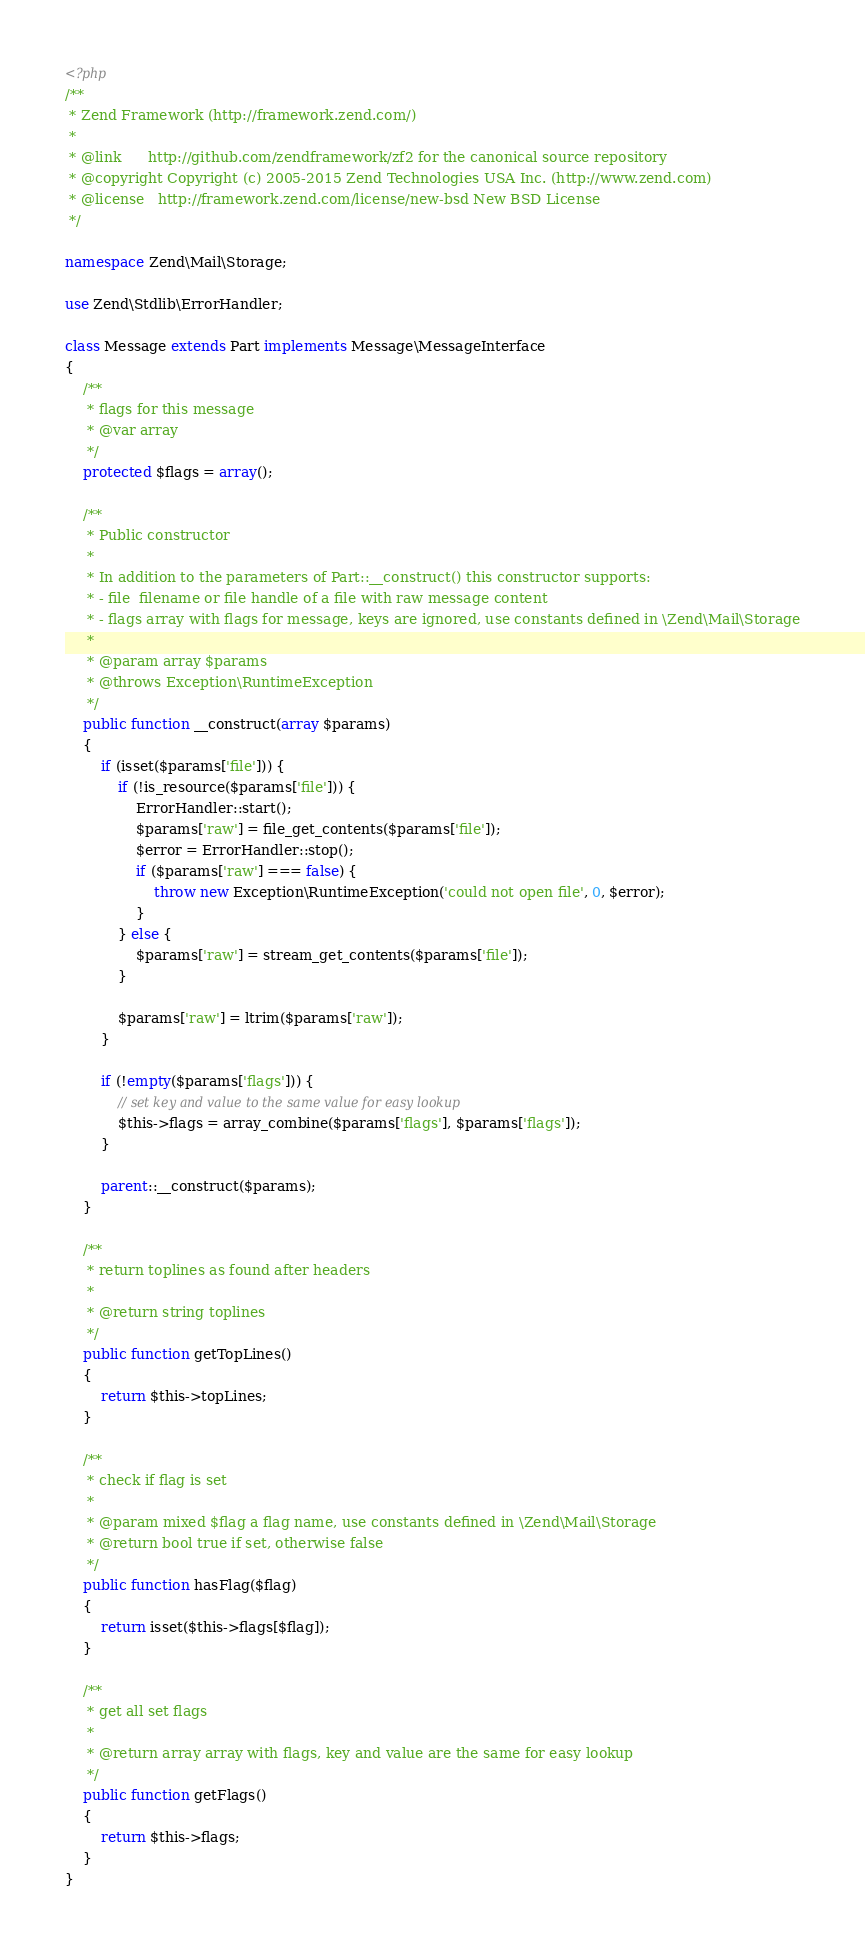<code> <loc_0><loc_0><loc_500><loc_500><_PHP_><?php
/**
 * Zend Framework (http://framework.zend.com/)
 *
 * @link      http://github.com/zendframework/zf2 for the canonical source repository
 * @copyright Copyright (c) 2005-2015 Zend Technologies USA Inc. (http://www.zend.com)
 * @license   http://framework.zend.com/license/new-bsd New BSD License
 */

namespace Zend\Mail\Storage;

use Zend\Stdlib\ErrorHandler;

class Message extends Part implements Message\MessageInterface
{
    /**
     * flags for this message
     * @var array
     */
    protected $flags = array();

    /**
     * Public constructor
     *
     * In addition to the parameters of Part::__construct() this constructor supports:
     * - file  filename or file handle of a file with raw message content
     * - flags array with flags for message, keys are ignored, use constants defined in \Zend\Mail\Storage
     *
     * @param array $params
     * @throws Exception\RuntimeException
     */
    public function __construct(array $params)
    {
        if (isset($params['file'])) {
            if (!is_resource($params['file'])) {
                ErrorHandler::start();
                $params['raw'] = file_get_contents($params['file']);
                $error = ErrorHandler::stop();
                if ($params['raw'] === false) {
                    throw new Exception\RuntimeException('could not open file', 0, $error);
                }
            } else {
                $params['raw'] = stream_get_contents($params['file']);
            }

            $params['raw'] = ltrim($params['raw']);
        }

        if (!empty($params['flags'])) {
            // set key and value to the same value for easy lookup
            $this->flags = array_combine($params['flags'], $params['flags']);
        }

        parent::__construct($params);
    }

    /**
     * return toplines as found after headers
     *
     * @return string toplines
     */
    public function getTopLines()
    {
        return $this->topLines;
    }

    /**
     * check if flag is set
     *
     * @param mixed $flag a flag name, use constants defined in \Zend\Mail\Storage
     * @return bool true if set, otherwise false
     */
    public function hasFlag($flag)
    {
        return isset($this->flags[$flag]);
    }

    /**
     * get all set flags
     *
     * @return array array with flags, key and value are the same for easy lookup
     */
    public function getFlags()
    {
        return $this->flags;
    }
}
</code> 